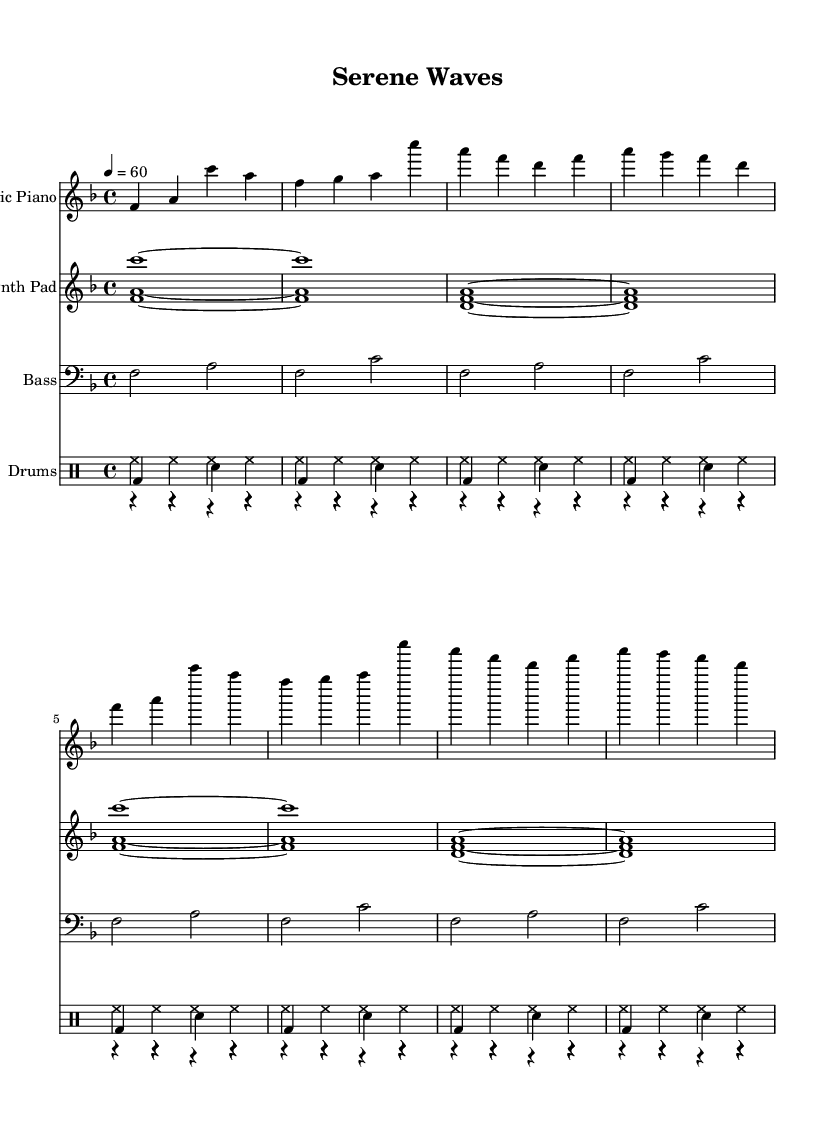What is the key signature of this music? The key signature is F major, which has one flat (B flat). This can be identified at the beginning of the music staff where the F major key signature is indicated.
Answer: F major What is the time signature of this music? The time signature is 4/4, which is indicated at the beginning of the music. This means there are four beats in each measure and a quarter note gets one beat.
Answer: 4/4 What is the tempo marking of this piece? The tempo marking is 60 beats per minute, which is written above the first measure of the score. This indicates the piece should be played slowly.
Answer: 60 How many measures are in the electric piano part? The electric piano part consists of 8 measures as observed by counting the number of time divisions (bars) in that part.
Answer: 8 measures Which instrument plays the bass line? The bass line is played by the Bass guitar, which is labeled at the beginning of that staff. This is also identifiable by the clef used (bass clef).
Answer: Bass guitar Is there a use of synthesizer sounds in this music? Yes, the Synth Pad is used, which is indicated at the beginning of the synth part. The synth sounds provide a smooth and calming texture typical in R&B instrumental music.
Answer: Yes What is the role of the drums in this piece? The drums provide a supportive rhythm, shown by the separate drum staff which includes kick, snare, and hi-hat patterns. They maintain the steady beat and add dynamic texture to the music.
Answer: Supportive rhythm 